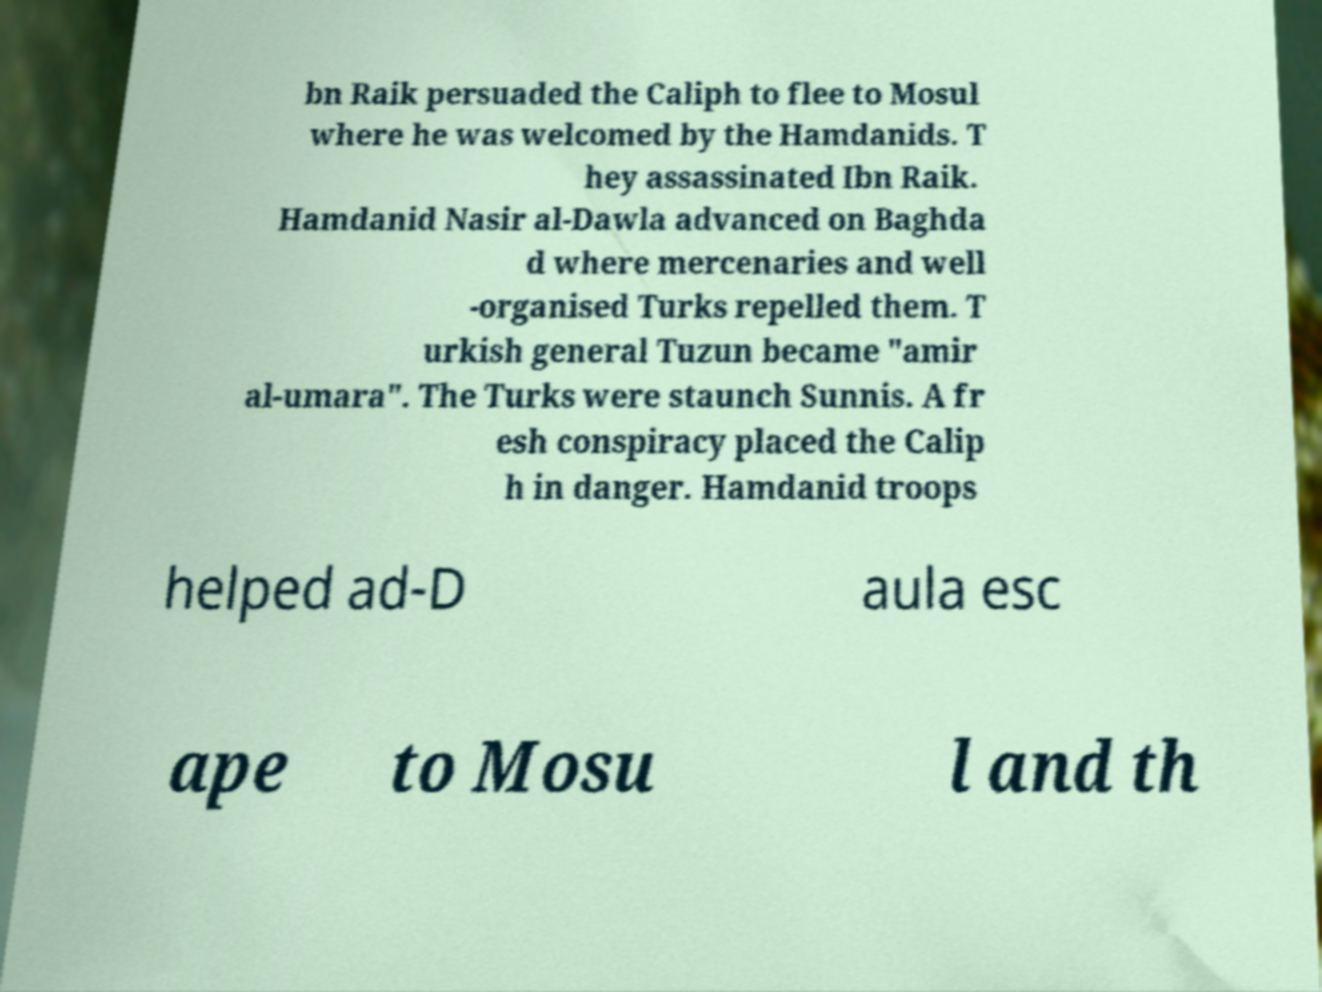Can you read and provide the text displayed in the image?This photo seems to have some interesting text. Can you extract and type it out for me? bn Raik persuaded the Caliph to flee to Mosul where he was welcomed by the Hamdanids. T hey assassinated Ibn Raik. Hamdanid Nasir al-Dawla advanced on Baghda d where mercenaries and well -organised Turks repelled them. T urkish general Tuzun became "amir al-umara". The Turks were staunch Sunnis. A fr esh conspiracy placed the Calip h in danger. Hamdanid troops helped ad-D aula esc ape to Mosu l and th 